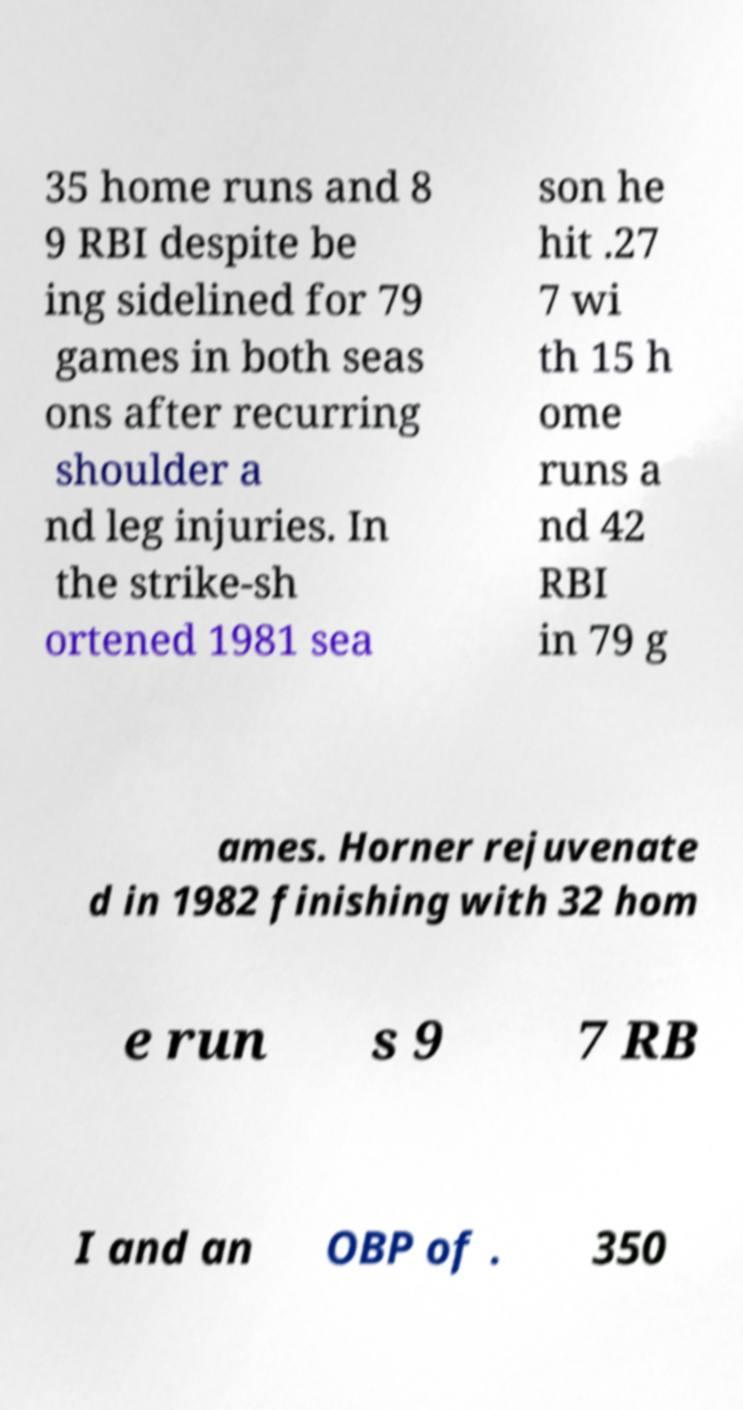Could you extract and type out the text from this image? 35 home runs and 8 9 RBI despite be ing sidelined for 79 games in both seas ons after recurring shoulder a nd leg injuries. In the strike-sh ortened 1981 sea son he hit .27 7 wi th 15 h ome runs a nd 42 RBI in 79 g ames. Horner rejuvenate d in 1982 finishing with 32 hom e run s 9 7 RB I and an OBP of . 350 